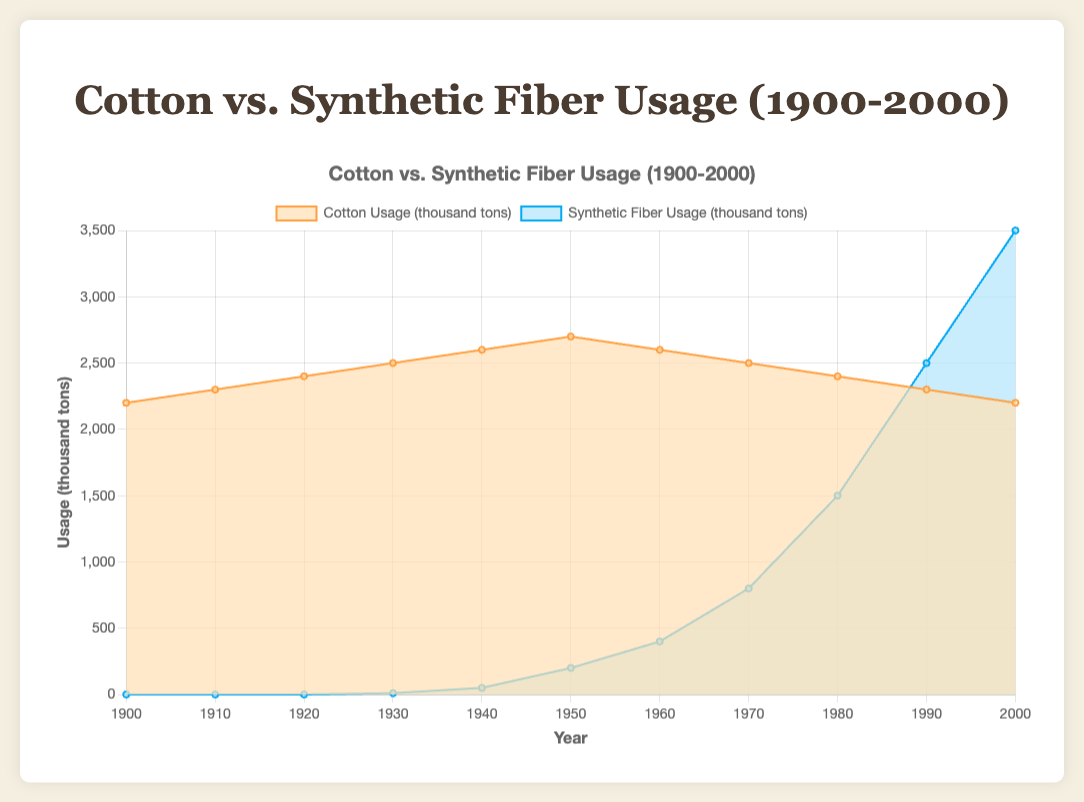What is the title of the chart? The title of the chart is prominently displayed at the top of the figure. It reads "Cotton vs. Synthetic Fiber Usage (1900-2000)."
Answer: Cotton vs. Synthetic Fiber Usage (1900-2000) How many data points are there for cotton usage? By counting the data points for cotton usage along the X-axis, we observe that there are data points for each decade from 1900 to 2000, resulting in a total of 11 data points.
Answer: 11 What are the colors used to represent cotton usage and synthetic fiber usage? The chart uses a light orange color for cotton usage and a light blue color for synthetic fiber usage, which helps distinguish between the two data series.
Answer: Light orange and light blue In which decade did synthetic fiber usage first appear? Synthetic fiber usage first appeared in the decade between 1920 and 1930, as indicated by the introduction of the light blue area on the chart.
Answer: 1930s Which year shows the highest usage of synthetic fibers? By tracing the blue area on the chart, the highest point for synthetic fiber usage is observed in the year 2000, where it reaches 3500 thousand tons.
Answer: 2000 How does the usage of cotton in 1900 compare to 2000? In the year 1900, cotton usage was 2200 thousand tons, while in 2000, it remained the same at 2200 thousand tons, indicating no net change over the century.
Answer: No change What is the combined usage of cotton and synthetic fibers in 1960? To find the combined usage, sum the values of cotton (2600 thousand tons) and synthetic fibers (400 thousand tons) in 1960: 2600 + 400 = 3000 thousand tons.
Answer: 3000 thousand tons Which decade saw the largest increase in synthetic fiber usage? By examining the decade-by-decade increase in synthetic fiber usage, the biggest jump is between 1980 and 1990, where usage increased from 1500 thousand tons to 2500 thousand tons, a rise of 1000 thousand tons.
Answer: 1980s to 1990s In which year did synthetic fiber usage surpass cotton usage? In the chart, synthetic fiber usage surpasses cotton usage in the year 1990, where synthetic fibers used are 2500 thousand tons compared to cotton's 2300 thousand tons.
Answer: 1990 What trend can be observed in the usage of cotton from 1950 to 2000? The chart shows a gradual decline in cotton usage from 2700 thousand tons in 1950 to 2200 thousand tons in 2000, indicating a downward trend over this period.
Answer: Gradual decline 